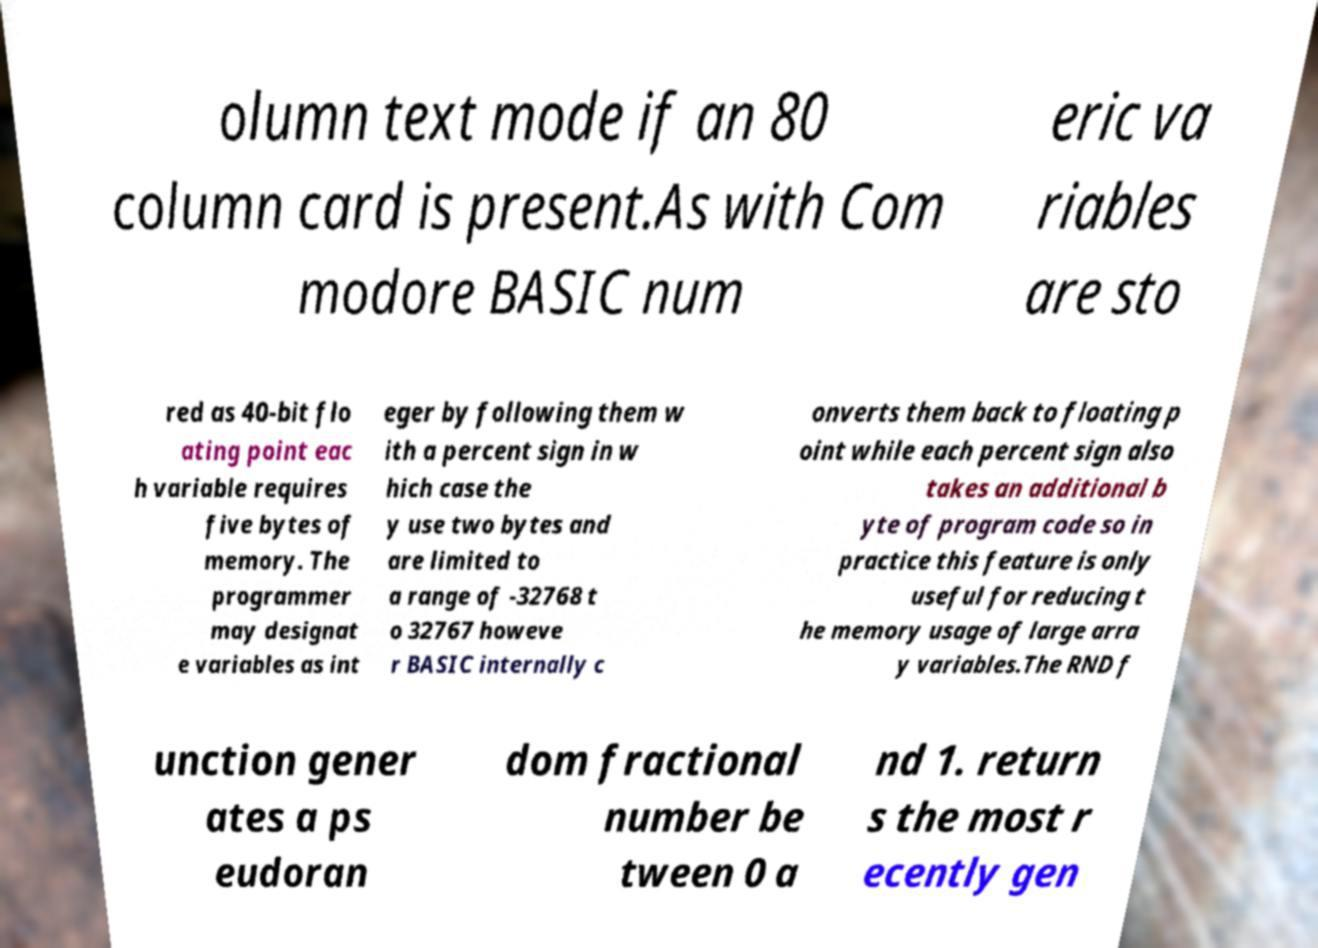Could you extract and type out the text from this image? olumn text mode if an 80 column card is present.As with Com modore BASIC num eric va riables are sto red as 40-bit flo ating point eac h variable requires five bytes of memory. The programmer may designat e variables as int eger by following them w ith a percent sign in w hich case the y use two bytes and are limited to a range of -32768 t o 32767 howeve r BASIC internally c onverts them back to floating p oint while each percent sign also takes an additional b yte of program code so in practice this feature is only useful for reducing t he memory usage of large arra y variables.The RND f unction gener ates a ps eudoran dom fractional number be tween 0 a nd 1. return s the most r ecently gen 